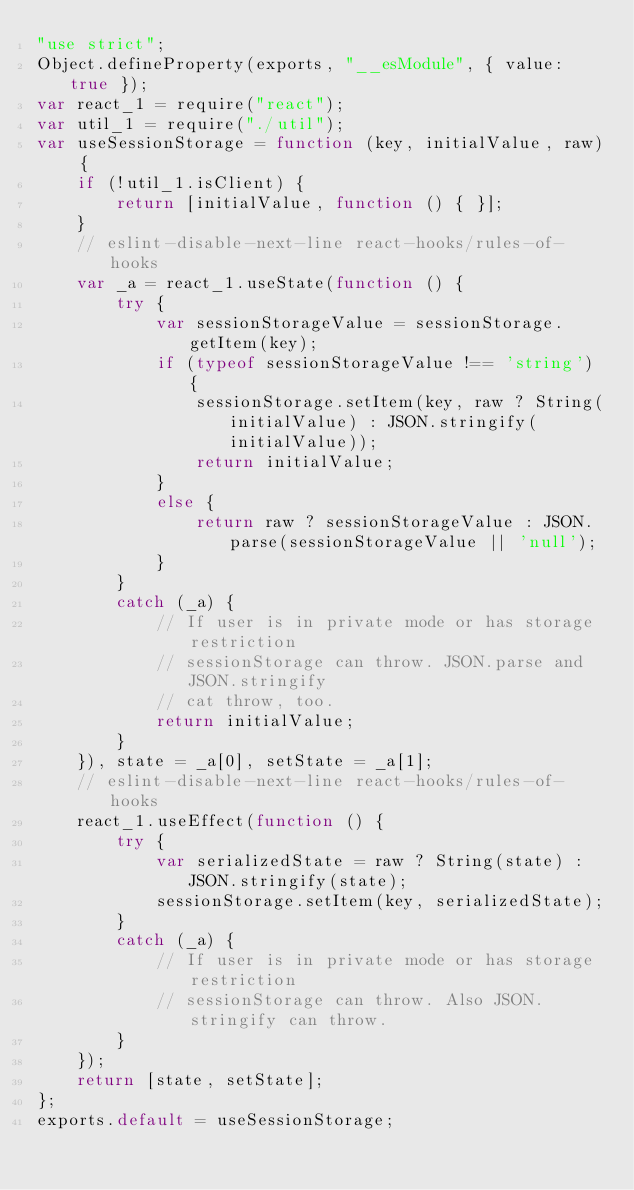<code> <loc_0><loc_0><loc_500><loc_500><_JavaScript_>"use strict";
Object.defineProperty(exports, "__esModule", { value: true });
var react_1 = require("react");
var util_1 = require("./util");
var useSessionStorage = function (key, initialValue, raw) {
    if (!util_1.isClient) {
        return [initialValue, function () { }];
    }
    // eslint-disable-next-line react-hooks/rules-of-hooks
    var _a = react_1.useState(function () {
        try {
            var sessionStorageValue = sessionStorage.getItem(key);
            if (typeof sessionStorageValue !== 'string') {
                sessionStorage.setItem(key, raw ? String(initialValue) : JSON.stringify(initialValue));
                return initialValue;
            }
            else {
                return raw ? sessionStorageValue : JSON.parse(sessionStorageValue || 'null');
            }
        }
        catch (_a) {
            // If user is in private mode or has storage restriction
            // sessionStorage can throw. JSON.parse and JSON.stringify
            // cat throw, too.
            return initialValue;
        }
    }), state = _a[0], setState = _a[1];
    // eslint-disable-next-line react-hooks/rules-of-hooks
    react_1.useEffect(function () {
        try {
            var serializedState = raw ? String(state) : JSON.stringify(state);
            sessionStorage.setItem(key, serializedState);
        }
        catch (_a) {
            // If user is in private mode or has storage restriction
            // sessionStorage can throw. Also JSON.stringify can throw.
        }
    });
    return [state, setState];
};
exports.default = useSessionStorage;
</code> 